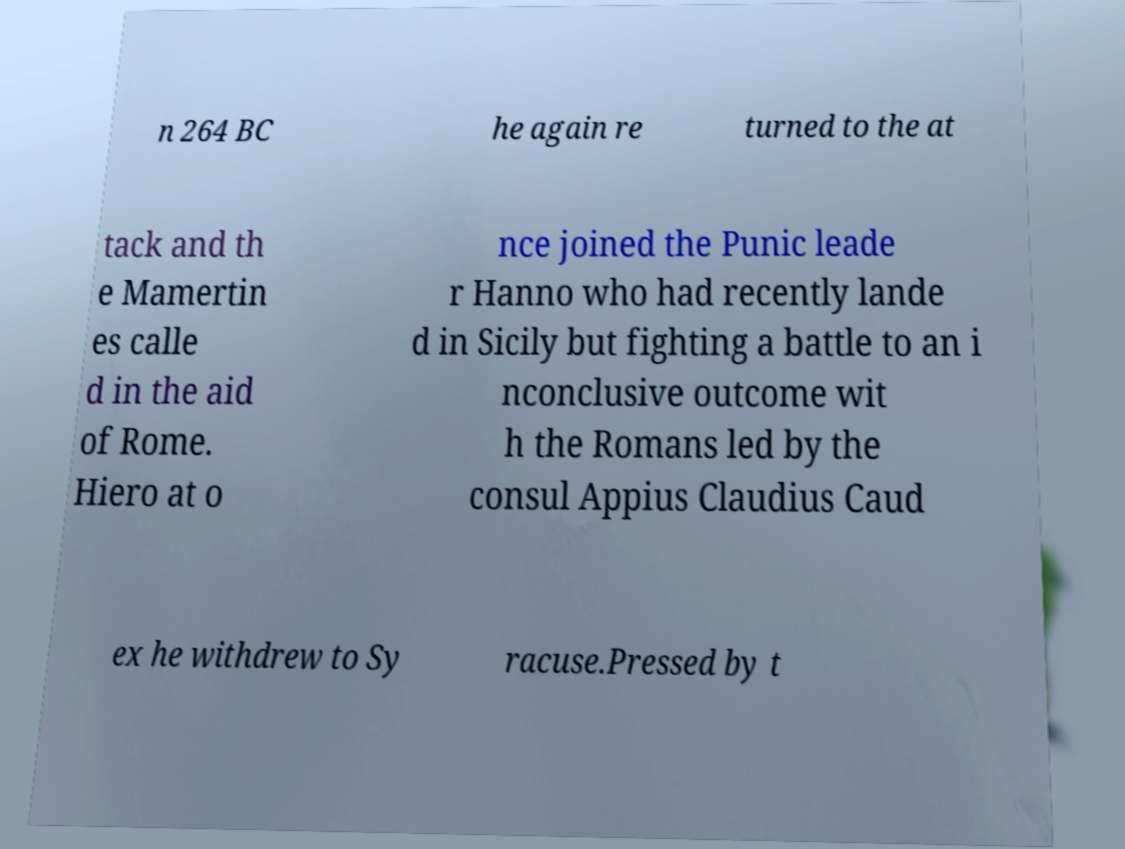What messages or text are displayed in this image? I need them in a readable, typed format. n 264 BC he again re turned to the at tack and th e Mamertin es calle d in the aid of Rome. Hiero at o nce joined the Punic leade r Hanno who had recently lande d in Sicily but fighting a battle to an i nconclusive outcome wit h the Romans led by the consul Appius Claudius Caud ex he withdrew to Sy racuse.Pressed by t 